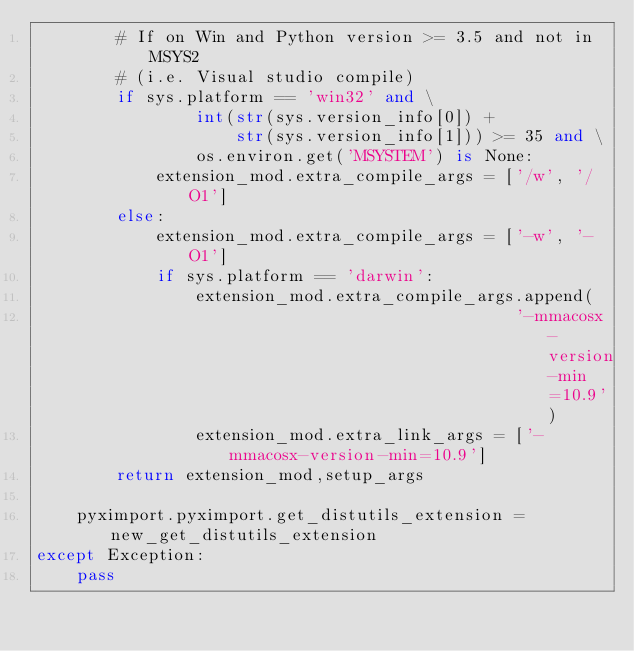Convert code to text. <code><loc_0><loc_0><loc_500><loc_500><_Python_>        # If on Win and Python version >= 3.5 and not in MSYS2
        # (i.e. Visual studio compile)
        if sys.platform == 'win32' and \
                int(str(sys.version_info[0]) +
                    str(sys.version_info[1])) >= 35 and \
                os.environ.get('MSYSTEM') is None:
            extension_mod.extra_compile_args = ['/w', '/O1']
        else:
            extension_mod.extra_compile_args = ['-w', '-O1']
            if sys.platform == 'darwin':
                extension_mod.extra_compile_args.append(
                                                '-mmacosx-version-min=10.9')
                extension_mod.extra_link_args = ['-mmacosx-version-min=10.9']
        return extension_mod,setup_args

    pyximport.pyximport.get_distutils_extension = new_get_distutils_extension
except Exception:
    pass
</code> 